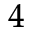Convert formula to latex. <formula><loc_0><loc_0><loc_500><loc_500>^ { 4 }</formula> 